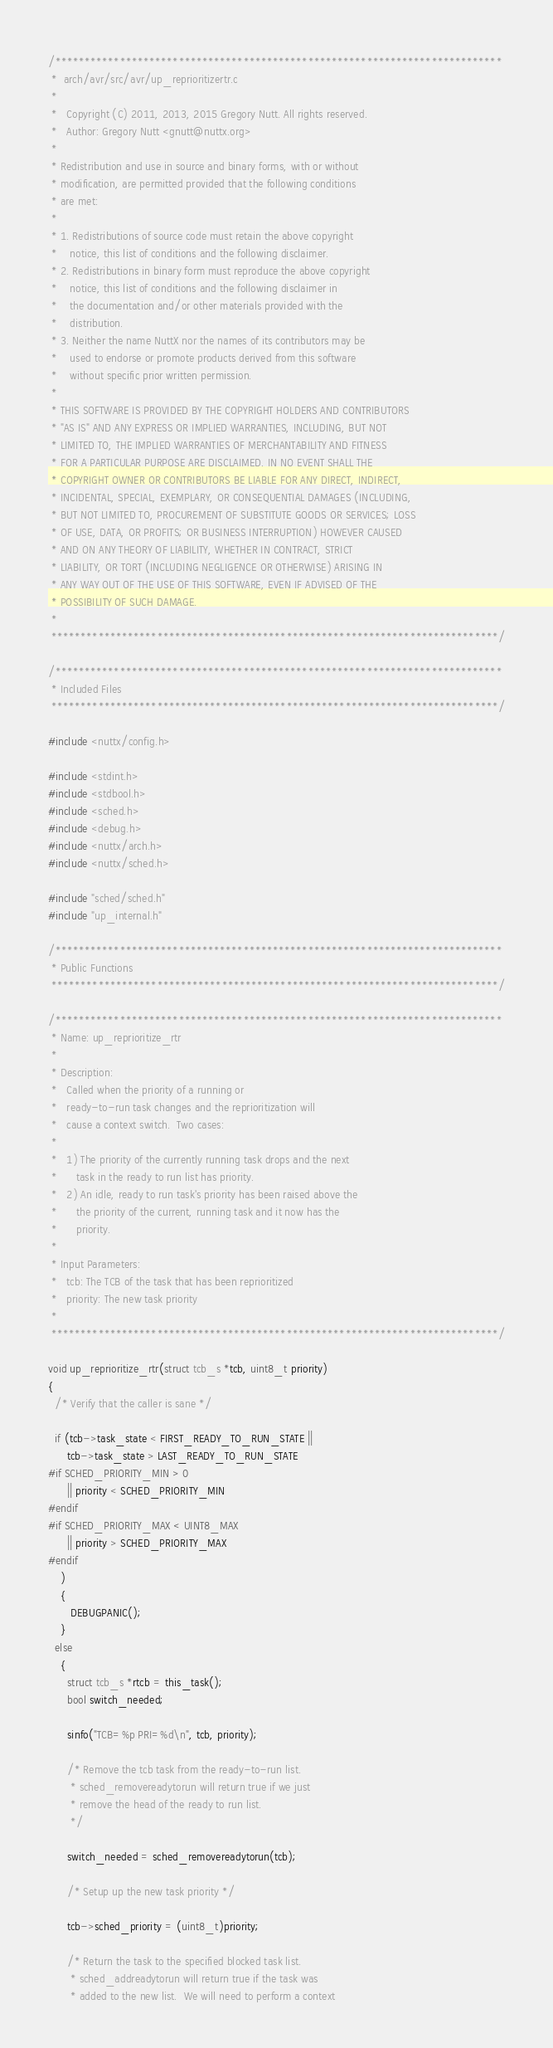<code> <loc_0><loc_0><loc_500><loc_500><_C_>/****************************************************************************
 *  arch/avr/src/avr/up_reprioritizertr.c
 *
 *   Copyright (C) 2011, 2013, 2015 Gregory Nutt. All rights reserved.
 *   Author: Gregory Nutt <gnutt@nuttx.org>
 *
 * Redistribution and use in source and binary forms, with or without
 * modification, are permitted provided that the following conditions
 * are met:
 *
 * 1. Redistributions of source code must retain the above copyright
 *    notice, this list of conditions and the following disclaimer.
 * 2. Redistributions in binary form must reproduce the above copyright
 *    notice, this list of conditions and the following disclaimer in
 *    the documentation and/or other materials provided with the
 *    distribution.
 * 3. Neither the name NuttX nor the names of its contributors may be
 *    used to endorse or promote products derived from this software
 *    without specific prior written permission.
 *
 * THIS SOFTWARE IS PROVIDED BY THE COPYRIGHT HOLDERS AND CONTRIBUTORS
 * "AS IS" AND ANY EXPRESS OR IMPLIED WARRANTIES, INCLUDING, BUT NOT
 * LIMITED TO, THE IMPLIED WARRANTIES OF MERCHANTABILITY AND FITNESS
 * FOR A PARTICULAR PURPOSE ARE DISCLAIMED. IN NO EVENT SHALL THE
 * COPYRIGHT OWNER OR CONTRIBUTORS BE LIABLE FOR ANY DIRECT, INDIRECT,
 * INCIDENTAL, SPECIAL, EXEMPLARY, OR CONSEQUENTIAL DAMAGES (INCLUDING,
 * BUT NOT LIMITED TO, PROCUREMENT OF SUBSTITUTE GOODS OR SERVICES; LOSS
 * OF USE, DATA, OR PROFITS; OR BUSINESS INTERRUPTION) HOWEVER CAUSED
 * AND ON ANY THEORY OF LIABILITY, WHETHER IN CONTRACT, STRICT
 * LIABILITY, OR TORT (INCLUDING NEGLIGENCE OR OTHERWISE) ARISING IN
 * ANY WAY OUT OF THE USE OF THIS SOFTWARE, EVEN IF ADVISED OF THE
 * POSSIBILITY OF SUCH DAMAGE.
 *
 ****************************************************************************/

/****************************************************************************
 * Included Files
 ****************************************************************************/

#include <nuttx/config.h>

#include <stdint.h>
#include <stdbool.h>
#include <sched.h>
#include <debug.h>
#include <nuttx/arch.h>
#include <nuttx/sched.h>

#include "sched/sched.h"
#include "up_internal.h"

/****************************************************************************
 * Public Functions
 ****************************************************************************/

/****************************************************************************
 * Name: up_reprioritize_rtr
 *
 * Description:
 *   Called when the priority of a running or
 *   ready-to-run task changes and the reprioritization will
 *   cause a context switch.  Two cases:
 *
 *   1) The priority of the currently running task drops and the next
 *      task in the ready to run list has priority.
 *   2) An idle, ready to run task's priority has been raised above the
 *      the priority of the current, running task and it now has the
 *      priority.
 *
 * Input Parameters:
 *   tcb: The TCB of the task that has been reprioritized
 *   priority: The new task priority
 *
 ****************************************************************************/

void up_reprioritize_rtr(struct tcb_s *tcb, uint8_t priority)
{
  /* Verify that the caller is sane */

  if (tcb->task_state < FIRST_READY_TO_RUN_STATE ||
      tcb->task_state > LAST_READY_TO_RUN_STATE
#if SCHED_PRIORITY_MIN > 0
      || priority < SCHED_PRIORITY_MIN
#endif
#if SCHED_PRIORITY_MAX < UINT8_MAX
      || priority > SCHED_PRIORITY_MAX
#endif
    )
    {
       DEBUGPANIC();
    }
  else
    {
      struct tcb_s *rtcb = this_task();
      bool switch_needed;

      sinfo("TCB=%p PRI=%d\n", tcb, priority);

      /* Remove the tcb task from the ready-to-run list.
       * sched_removereadytorun will return true if we just
       * remove the head of the ready to run list.
       */

      switch_needed = sched_removereadytorun(tcb);

      /* Setup up the new task priority */

      tcb->sched_priority = (uint8_t)priority;

      /* Return the task to the specified blocked task list.
       * sched_addreadytorun will return true if the task was
       * added to the new list.  We will need to perform a context</code> 